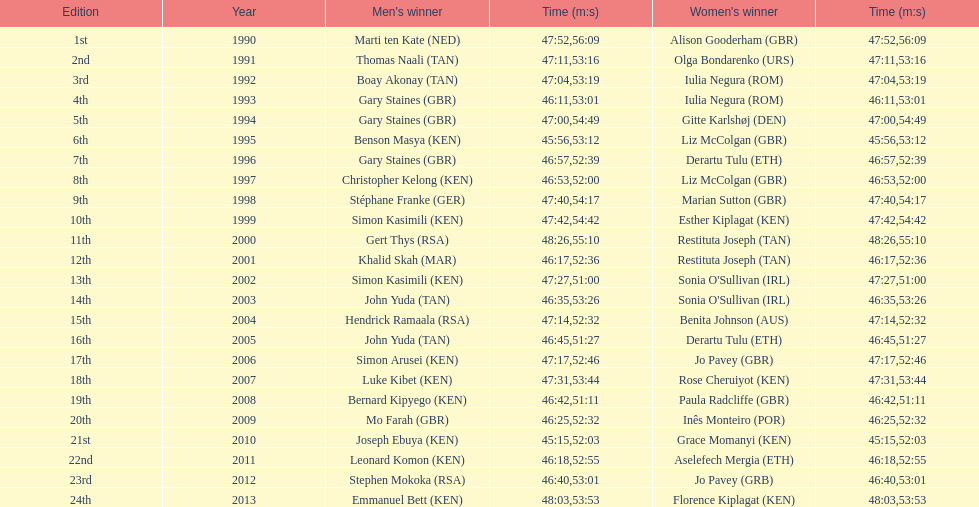How long did sonia o'sullivan take to finish in 2003? 53:26. 